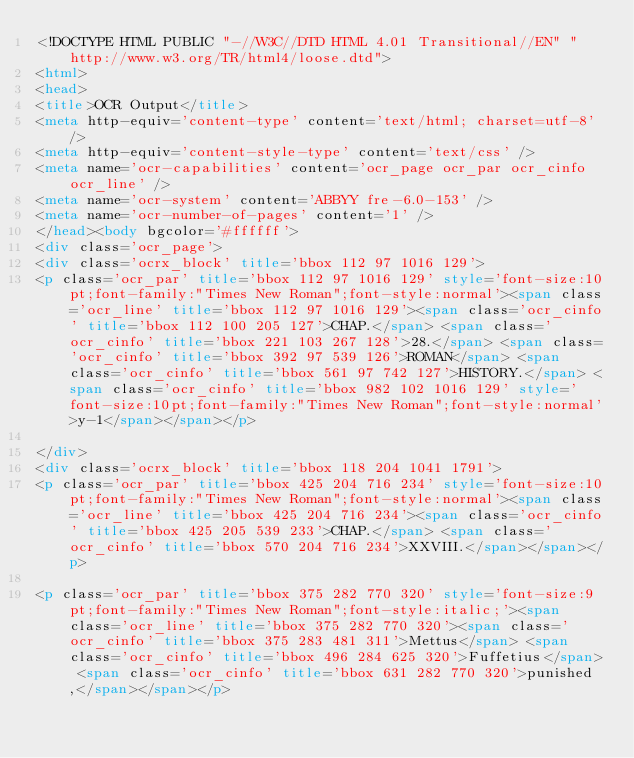<code> <loc_0><loc_0><loc_500><loc_500><_HTML_><!DOCTYPE HTML PUBLIC "-//W3C//DTD HTML 4.01 Transitional//EN" "http://www.w3.org/TR/html4/loose.dtd">
<html>
<head>
<title>OCR Output</title>
<meta http-equiv='content-type' content='text/html; charset=utf-8' />
<meta http-equiv='content-style-type' content='text/css' />
<meta name='ocr-capabilities' content='ocr_page ocr_par ocr_cinfo ocr_line' />
<meta name='ocr-system' content='ABBYY fre-6.0-153' />
<meta name='ocr-number-of-pages' content='1' />
</head><body bgcolor='#ffffff'>
<div class='ocr_page'>
<div class='ocrx_block' title='bbox 112 97 1016 129'>
<p class='ocr_par' title='bbox 112 97 1016 129' style='font-size:10pt;font-family:"Times New Roman";font-style:normal'><span class='ocr_line' title='bbox 112 97 1016 129'><span class='ocr_cinfo' title='bbox 112 100 205 127'>CHAP.</span> <span class='ocr_cinfo' title='bbox 221 103 267 128'>28.</span> <span class='ocr_cinfo' title='bbox 392 97 539 126'>ROMAN</span> <span class='ocr_cinfo' title='bbox 561 97 742 127'>HISTORY.</span> <span class='ocr_cinfo' title='bbox 982 102 1016 129' style='font-size:10pt;font-family:"Times New Roman";font-style:normal'>y-1</span></span></p>

</div>
<div class='ocrx_block' title='bbox 118 204 1041 1791'>
<p class='ocr_par' title='bbox 425 204 716 234' style='font-size:10pt;font-family:"Times New Roman";font-style:normal'><span class='ocr_line' title='bbox 425 204 716 234'><span class='ocr_cinfo' title='bbox 425 205 539 233'>CHAP.</span> <span class='ocr_cinfo' title='bbox 570 204 716 234'>XXVIII.</span></span></p>

<p class='ocr_par' title='bbox 375 282 770 320' style='font-size:9pt;font-family:"Times New Roman";font-style:italic;'><span class='ocr_line' title='bbox 375 282 770 320'><span class='ocr_cinfo' title='bbox 375 283 481 311'>Mettus</span> <span class='ocr_cinfo' title='bbox 496 284 625 320'>Fuffetius</span> <span class='ocr_cinfo' title='bbox 631 282 770 320'>punished,</span></span></p>
</code> 